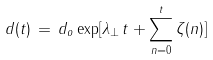Convert formula to latex. <formula><loc_0><loc_0><loc_500><loc_500>d ( t ) \, = \, d _ { o } \exp [ \lambda _ { \perp } \, t + \sum _ { n = 0 } ^ { t } \zeta ( n ) ]</formula> 